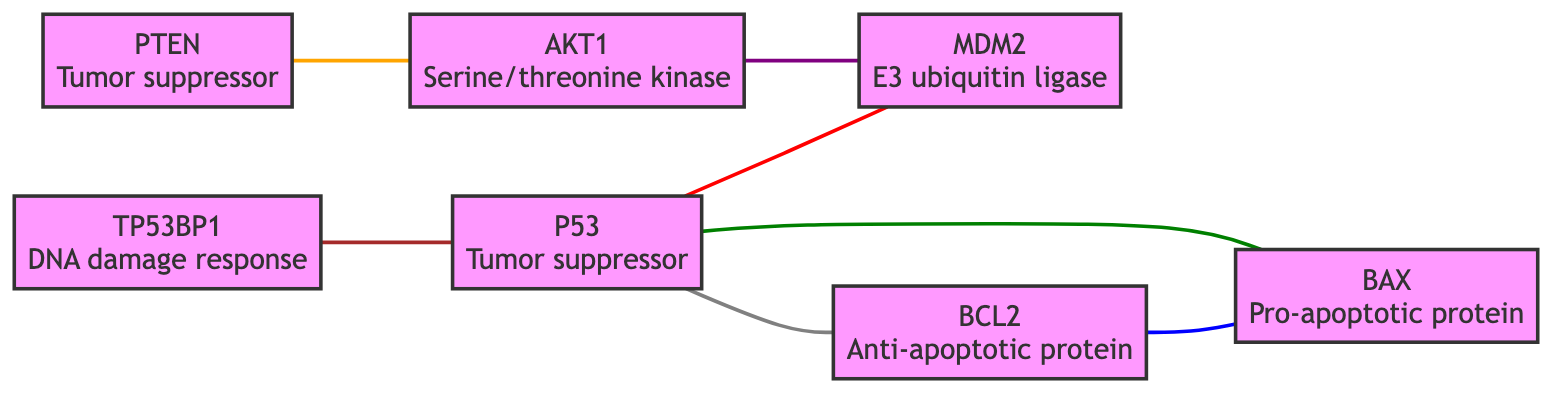What are the total number of nodes in the diagram? The diagram lists distinct entries under the "nodes" section, totaling seven different proteins involved in the interaction network.
Answer: 7 How many edges are depicted in the graph? By counting the individual connections listed under the "edges" section, we find there are a total of seven edges representing interactions between the proteins.
Answer: 7 Who inhibits BAX? The edge between BCL2 and BAX indicates that BCL2 is involved in inhibiting the pro-apoptotic effects of BAX, preventing apoptosis.
Answer: BCL2 What protein does P53 downregulate? The diagram indicates a direct connection from P53 to BCL2, with the description noting that P53 downregulates BCL2, promoting apoptosis instead.
Answer: BCL2 Which protein negatively regulates AKT1? PTEN is listed as the protein that negatively regulates the AKT1 signaling pathway in the diagram, as shown by the corresponding edge.
Answer: PTEN How many interactions does P53 have in total? By counting the edges connected to P53, we see that it interacts with MDM2, BAX, BCL2, and TP53BP1, totaling four different interactions overall.
Answer: 4 What is the relationship between AKT1 and MDM2? The edge between AKT1 and MDM2 shows that AKT1 phosphorylates and activates MDM2, which leads to the degradation of P53, highlighting a regulatory interaction.
Answer: AKT1 activates MDM2 Which proteins are directly connected to P53? The nodes directly linked to P53, as indicated by three edges, include MDM2, BAX, and BCL2, reflecting multiple regulatory relationships of P53.
Answer: MDM2, BAX, BCL2 Which two proteins act in a pathway regulating apoptosis? The diagram shows a connection between BAX (promotes apoptosis) and BCL2 (inhibits apoptosis), together illustrating the dual roles these proteins play in apoptotic signaling.
Answer: BAX and BCL2 